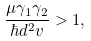Convert formula to latex. <formula><loc_0><loc_0><loc_500><loc_500>\frac { \mu \gamma _ { 1 } \gamma _ { 2 } } { \hbar { d } ^ { 2 } v } > 1 ,</formula> 